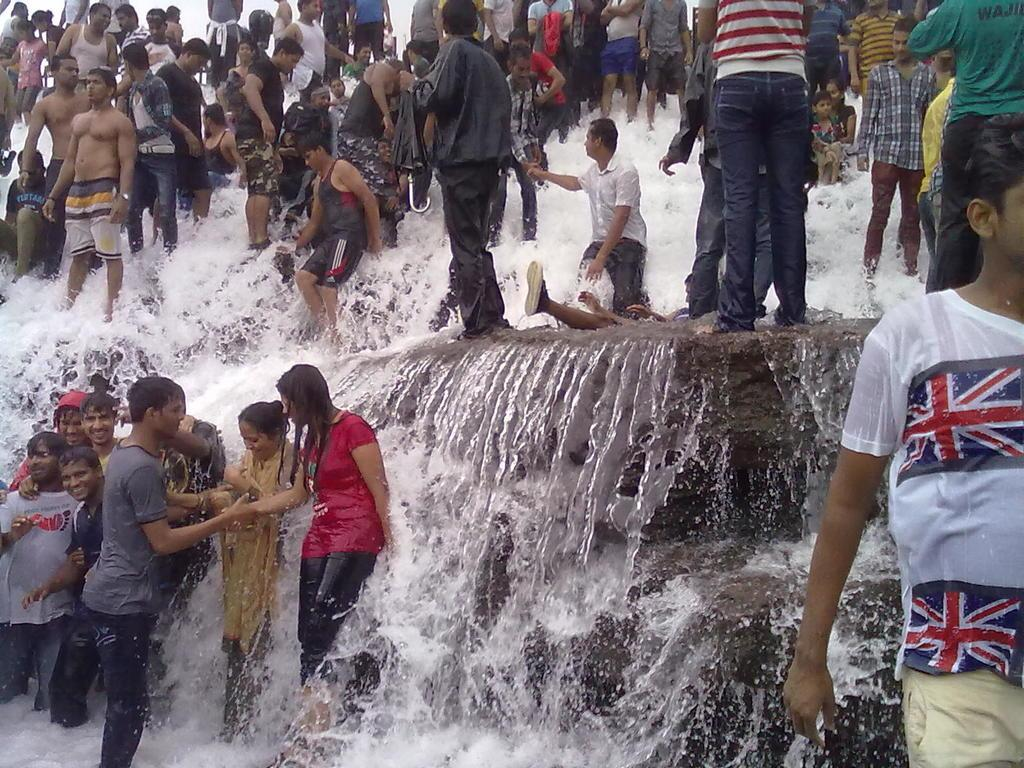How many people are in the image? There are people in the image, but the exact number is not specified. What are the people doing in the image? The people are standing on a waterfall. What disease is affecting the people standing on the waterfall in the image? There is no information about any disease affecting the people in the image. 